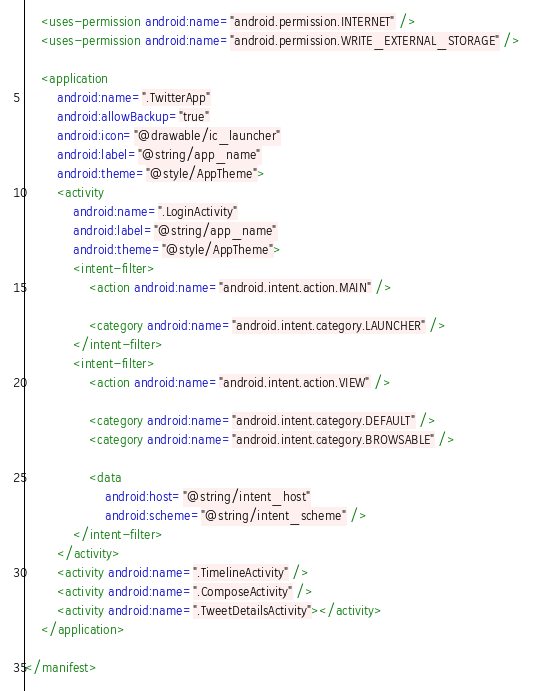Convert code to text. <code><loc_0><loc_0><loc_500><loc_500><_XML_>    <uses-permission android:name="android.permission.INTERNET" />
    <uses-permission android:name="android.permission.WRITE_EXTERNAL_STORAGE" />

    <application
        android:name=".TwitterApp"
        android:allowBackup="true"
        android:icon="@drawable/ic_launcher"
        android:label="@string/app_name"
        android:theme="@style/AppTheme">
        <activity
            android:name=".LoginActivity"
            android:label="@string/app_name"
            android:theme="@style/AppTheme">
            <intent-filter>
                <action android:name="android.intent.action.MAIN" />

                <category android:name="android.intent.category.LAUNCHER" />
            </intent-filter>
            <intent-filter>
                <action android:name="android.intent.action.VIEW" />

                <category android:name="android.intent.category.DEFAULT" />
                <category android:name="android.intent.category.BROWSABLE" />

                <data
                    android:host="@string/intent_host"
                    android:scheme="@string/intent_scheme" />
            </intent-filter>
        </activity>
        <activity android:name=".TimelineActivity" />
        <activity android:name=".ComposeActivity" />
        <activity android:name=".TweetDetailsActivity"></activity>
    </application>

</manifest></code> 